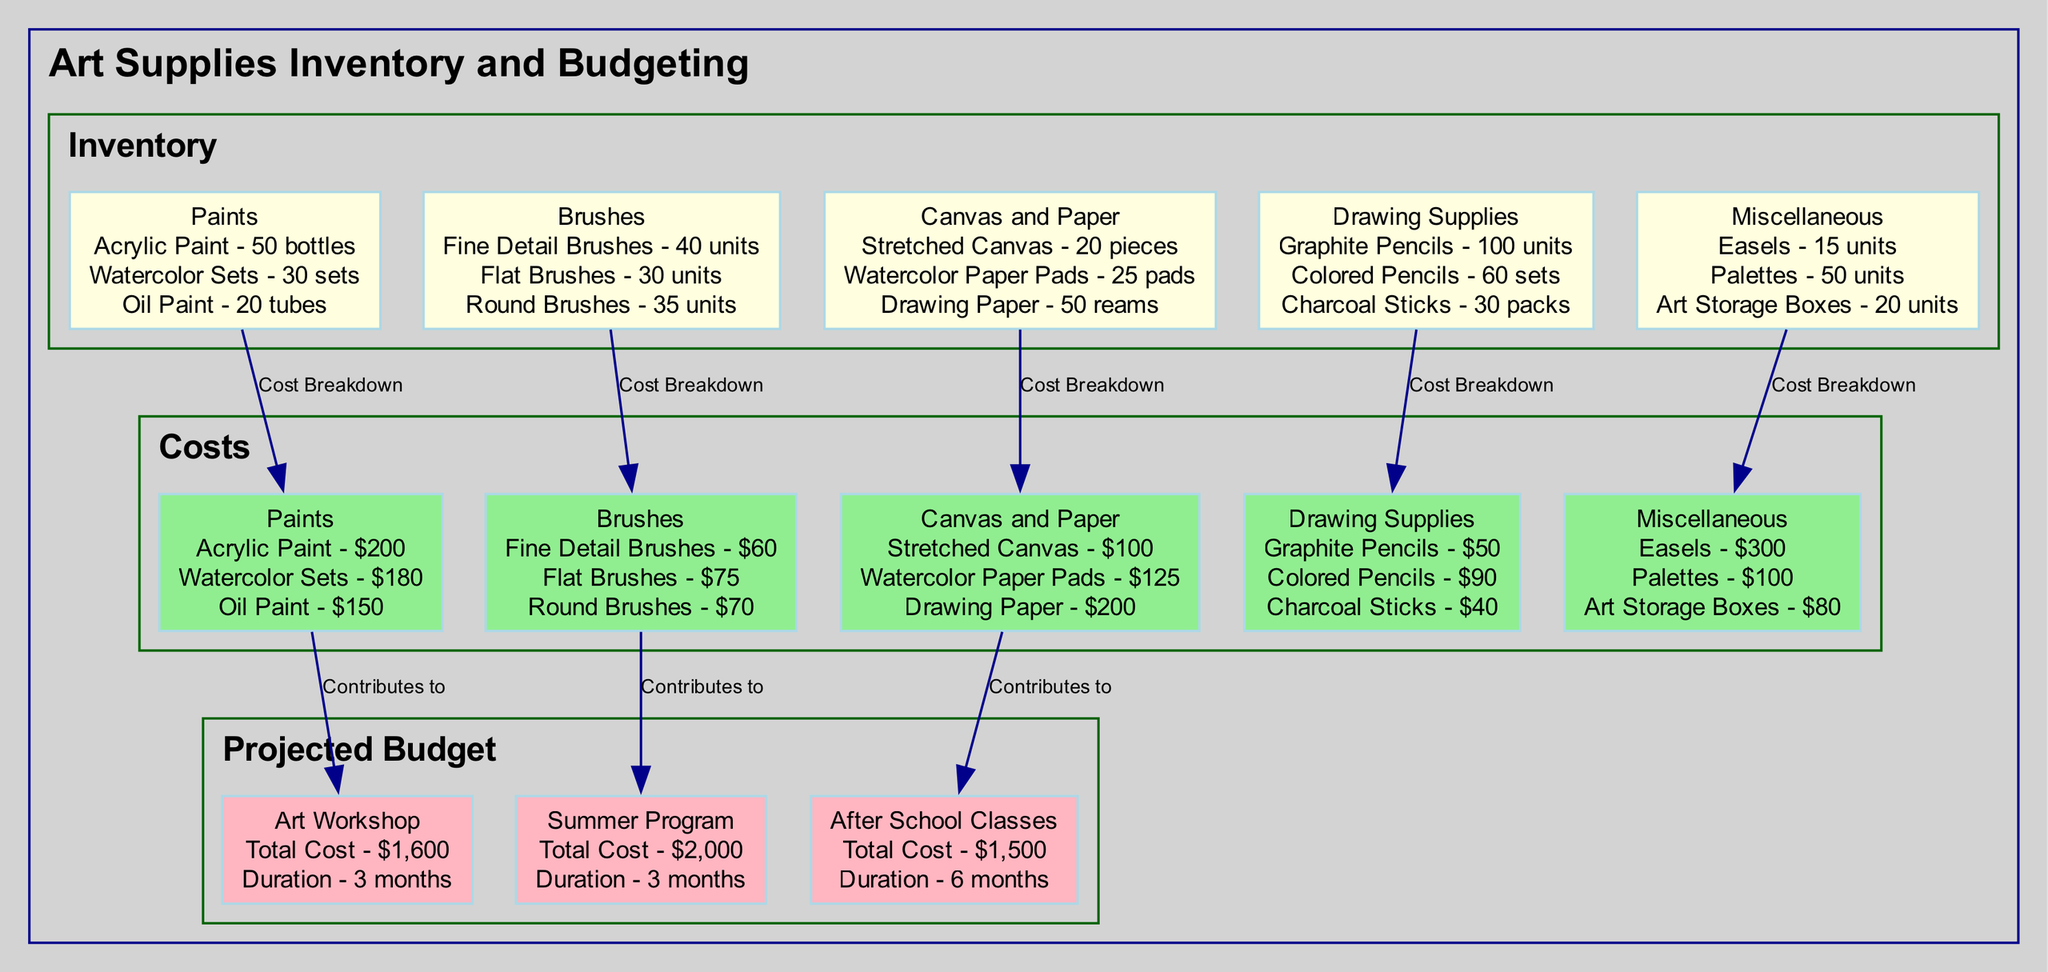What is the total cost for Paints? In the 'Costs' section, we look at the details under 'Paints', which includes Acrylic Paint for $200, Watercolor Sets for $180, and Oil Paint for $150. Adding these up gives us 200 + 180 + 150 = 530.
Answer: 530 How many units of Fine Detail Brushes are listed in the inventory? In the 'Inventory' section under 'Brushes', the details show Fine Detail Brushes with a quantity of 40 units.
Answer: 40 What contributions does Costs_Paints make to the Projected Budget? The edge connecting Costs_Paints to Projected Budget_Art Workshop indicates that it contributes to the budget for this art workshop project.
Answer: Art Workshop How many different categories of supplies are listed in the inventory? In the 'Inventory' section, there are 5 different categories detailed: Paints, Brushes, Canvas and Paper, Drawing Supplies, and Miscellaneous.
Answer: 5 What is the total projected budget for the Summer Program? In the 'Projected Budget' section, the total cost for the Summer Program is explicitly noted as $2000.
Answer: 2000 Which painting supplies cost more than $170? In the 'Costs' section under 'Paints', Watercolor Sets cost $180 and Acrylic Paint costs $200, which both exceed $170.
Answer: Watercolor Sets, Acrylic Paint Which category has the highest total expense? Analyzing the total costs in the 'Costs' section, we see that the Miscellaneous category (Easels $300, Palettes $100, Art Storage Boxes $80) has a total of 300 + 100 + 80 = 480, which is the highest compared to others.
Answer: Miscellaneous How many packs of Charcoal Sticks are included under Drawing Supplies? Under the 'Drawing Supplies' section in the 'Inventory', it specifies that there are 30 packs of Charcoal Sticks.
Answer: 30 What is the duration of the After School Classes project in the Projected Budget? The 'Projected Budget' section specifies that the After School Classes have a duration of 6 months.
Answer: 6 months 